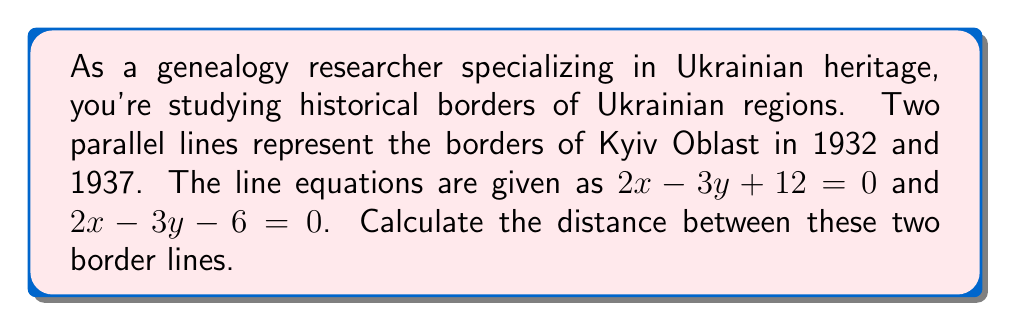What is the answer to this math problem? To find the distance between two parallel lines, we can use the formula:

$$d = \frac{|c_2 - c_1|}{\sqrt{a^2 + b^2}}$$

Where $(ax + by + c_1 = 0)$ and $(ax + by + c_2 = 0)$ are the equations of the two parallel lines.

Step 1: Identify the components of the formula from the given equations.
$2x - 3y + 12 = 0$ and $2x - 3y - 6 = 0$
$a = 2$, $b = -3$, $c_1 = 12$, $c_2 = -6$

Step 2: Calculate $|c_2 - c_1|$
$|c_2 - c_1| = |-6 - 12| = |-18| = 18$

Step 3: Calculate $\sqrt{a^2 + b^2}$
$\sqrt{a^2 + b^2} = \sqrt{2^2 + (-3)^2} = \sqrt{4 + 9} = \sqrt{13}$

Step 4: Apply the formula
$$d = \frac{18}{\sqrt{13}}$$

Step 5: Simplify the fraction
$$d = \frac{18}{\sqrt{13}} = \frac{18\sqrt{13}}{13} \approx 4.99$$

The distance between the two border lines is $\frac{18\sqrt{13}}{13}$ units, which is approximately 4.99 units.
Answer: $\frac{18\sqrt{13}}{13}$ units 